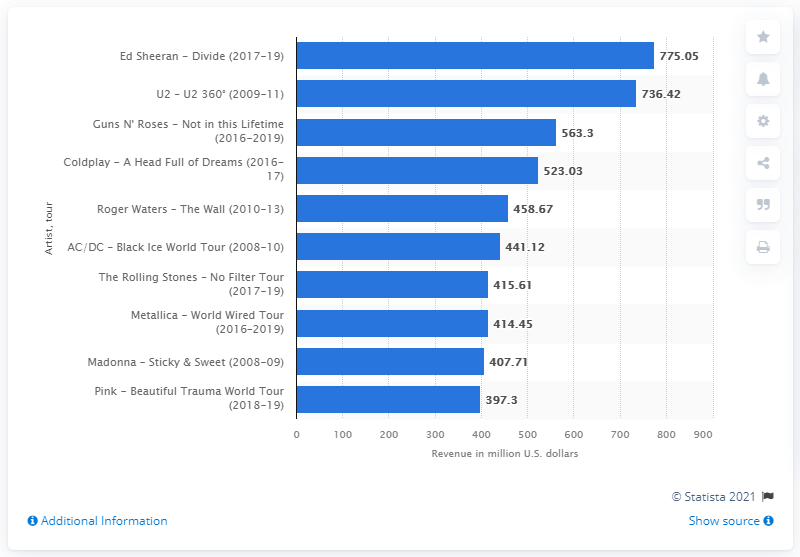Give some essential details in this illustration. The total revenue generated from U2's 360° Tour was approximately 736.42. 